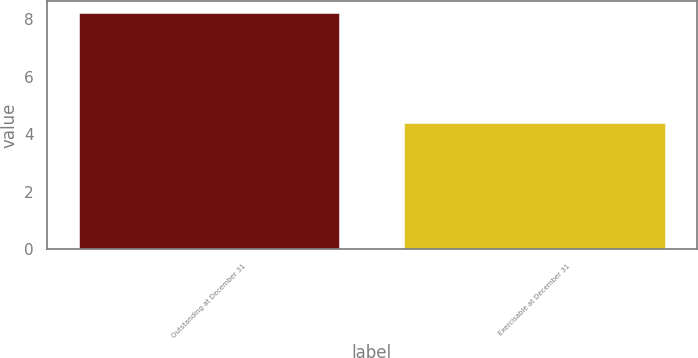<chart> <loc_0><loc_0><loc_500><loc_500><bar_chart><fcel>Outstanding at December 31<fcel>Exercisable at December 31<nl><fcel>8.2<fcel>4.4<nl></chart> 